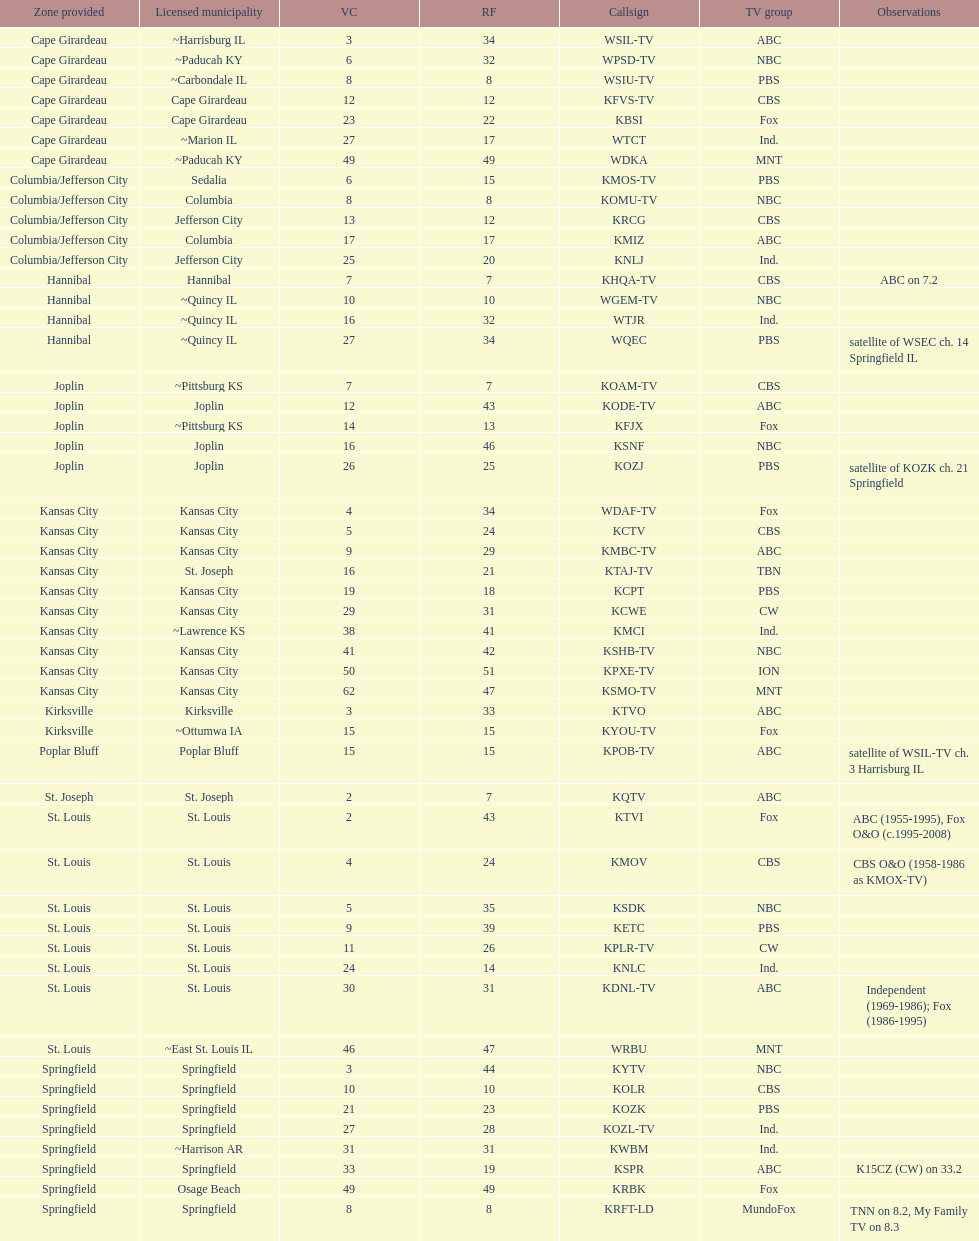How many are on the cbs network? 7. 